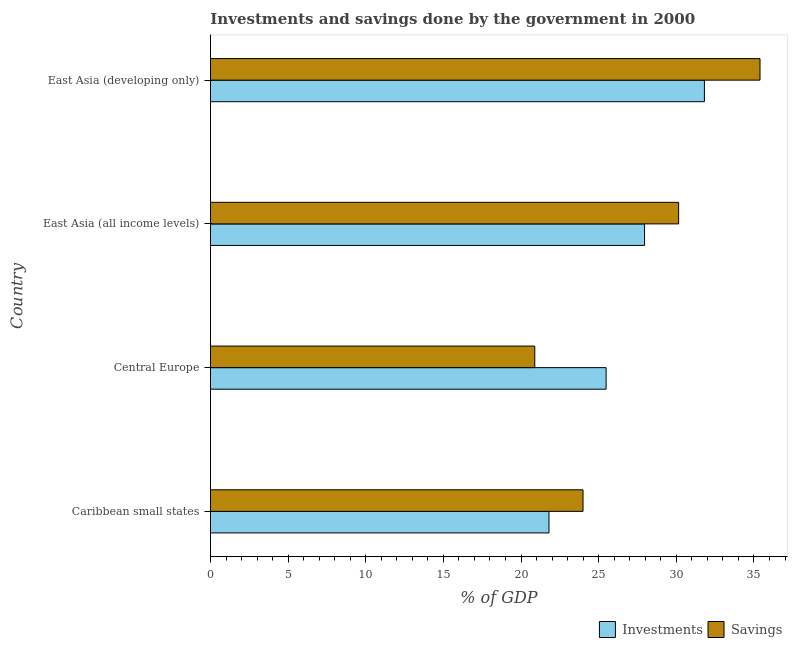How many groups of bars are there?
Your response must be concise. 4. Are the number of bars on each tick of the Y-axis equal?
Offer a terse response. Yes. How many bars are there on the 1st tick from the top?
Ensure brevity in your answer.  2. How many bars are there on the 3rd tick from the bottom?
Make the answer very short. 2. What is the label of the 4th group of bars from the top?
Offer a terse response. Caribbean small states. What is the investments of government in Central Europe?
Make the answer very short. 25.48. Across all countries, what is the maximum savings of government?
Offer a very short reply. 35.39. Across all countries, what is the minimum savings of government?
Your response must be concise. 20.89. In which country was the savings of government maximum?
Your answer should be compact. East Asia (developing only). In which country was the investments of government minimum?
Ensure brevity in your answer.  Caribbean small states. What is the total savings of government in the graph?
Keep it short and to the point. 110.42. What is the difference between the investments of government in East Asia (all income levels) and that in East Asia (developing only)?
Keep it short and to the point. -3.85. What is the difference between the savings of government in Caribbean small states and the investments of government in East Asia (all income levels)?
Ensure brevity in your answer.  -3.96. What is the average savings of government per country?
Offer a terse response. 27.61. What is the difference between the savings of government and investments of government in Central Europe?
Give a very brief answer. -4.59. In how many countries, is the savings of government greater than 18 %?
Your answer should be compact. 4. What is the ratio of the investments of government in East Asia (all income levels) to that in East Asia (developing only)?
Ensure brevity in your answer.  0.88. Is the investments of government in Caribbean small states less than that in Central Europe?
Offer a very short reply. Yes. What is the difference between the highest and the second highest investments of government?
Give a very brief answer. 3.85. What is the difference between the highest and the lowest savings of government?
Give a very brief answer. 14.51. In how many countries, is the investments of government greater than the average investments of government taken over all countries?
Provide a short and direct response. 2. Is the sum of the investments of government in Caribbean small states and East Asia (developing only) greater than the maximum savings of government across all countries?
Make the answer very short. Yes. What does the 1st bar from the top in Central Europe represents?
Your response must be concise. Savings. What does the 1st bar from the bottom in East Asia (all income levels) represents?
Ensure brevity in your answer.  Investments. Are all the bars in the graph horizontal?
Make the answer very short. Yes. How many countries are there in the graph?
Offer a very short reply. 4. What is the difference between two consecutive major ticks on the X-axis?
Provide a short and direct response. 5. Does the graph contain any zero values?
Give a very brief answer. No. Does the graph contain grids?
Ensure brevity in your answer.  No. Where does the legend appear in the graph?
Offer a very short reply. Bottom right. How many legend labels are there?
Provide a succinct answer. 2. What is the title of the graph?
Give a very brief answer. Investments and savings done by the government in 2000. Does "Domestic Liabilities" appear as one of the legend labels in the graph?
Keep it short and to the point. No. What is the label or title of the X-axis?
Give a very brief answer. % of GDP. What is the label or title of the Y-axis?
Keep it short and to the point. Country. What is the % of GDP of Investments in Caribbean small states?
Give a very brief answer. 21.8. What is the % of GDP of Savings in Caribbean small states?
Provide a short and direct response. 23.99. What is the % of GDP in Investments in Central Europe?
Make the answer very short. 25.48. What is the % of GDP in Savings in Central Europe?
Your answer should be compact. 20.89. What is the % of GDP in Investments in East Asia (all income levels)?
Give a very brief answer. 27.96. What is the % of GDP in Savings in East Asia (all income levels)?
Give a very brief answer. 30.15. What is the % of GDP in Investments in East Asia (developing only)?
Make the answer very short. 31.81. What is the % of GDP of Savings in East Asia (developing only)?
Your response must be concise. 35.39. Across all countries, what is the maximum % of GDP in Investments?
Your answer should be compact. 31.81. Across all countries, what is the maximum % of GDP in Savings?
Offer a very short reply. 35.39. Across all countries, what is the minimum % of GDP of Investments?
Your response must be concise. 21.8. Across all countries, what is the minimum % of GDP in Savings?
Provide a short and direct response. 20.89. What is the total % of GDP in Investments in the graph?
Keep it short and to the point. 107.04. What is the total % of GDP in Savings in the graph?
Keep it short and to the point. 110.42. What is the difference between the % of GDP of Investments in Caribbean small states and that in Central Europe?
Your answer should be very brief. -3.68. What is the difference between the % of GDP of Savings in Caribbean small states and that in Central Europe?
Your answer should be very brief. 3.11. What is the difference between the % of GDP of Investments in Caribbean small states and that in East Asia (all income levels)?
Your answer should be very brief. -6.16. What is the difference between the % of GDP in Savings in Caribbean small states and that in East Asia (all income levels)?
Give a very brief answer. -6.16. What is the difference between the % of GDP of Investments in Caribbean small states and that in East Asia (developing only)?
Make the answer very short. -10.01. What is the difference between the % of GDP in Savings in Caribbean small states and that in East Asia (developing only)?
Your response must be concise. -11.4. What is the difference between the % of GDP in Investments in Central Europe and that in East Asia (all income levels)?
Your answer should be compact. -2.48. What is the difference between the % of GDP in Savings in Central Europe and that in East Asia (all income levels)?
Provide a short and direct response. -9.26. What is the difference between the % of GDP of Investments in Central Europe and that in East Asia (developing only)?
Your answer should be compact. -6.33. What is the difference between the % of GDP of Savings in Central Europe and that in East Asia (developing only)?
Provide a short and direct response. -14.51. What is the difference between the % of GDP of Investments in East Asia (all income levels) and that in East Asia (developing only)?
Make the answer very short. -3.85. What is the difference between the % of GDP of Savings in East Asia (all income levels) and that in East Asia (developing only)?
Give a very brief answer. -5.24. What is the difference between the % of GDP of Investments in Caribbean small states and the % of GDP of Savings in Central Europe?
Keep it short and to the point. 0.91. What is the difference between the % of GDP of Investments in Caribbean small states and the % of GDP of Savings in East Asia (all income levels)?
Offer a terse response. -8.35. What is the difference between the % of GDP in Investments in Caribbean small states and the % of GDP in Savings in East Asia (developing only)?
Give a very brief answer. -13.59. What is the difference between the % of GDP in Investments in Central Europe and the % of GDP in Savings in East Asia (all income levels)?
Your response must be concise. -4.67. What is the difference between the % of GDP of Investments in Central Europe and the % of GDP of Savings in East Asia (developing only)?
Provide a succinct answer. -9.91. What is the difference between the % of GDP in Investments in East Asia (all income levels) and the % of GDP in Savings in East Asia (developing only)?
Ensure brevity in your answer.  -7.44. What is the average % of GDP of Investments per country?
Provide a succinct answer. 26.76. What is the average % of GDP in Savings per country?
Keep it short and to the point. 27.61. What is the difference between the % of GDP in Investments and % of GDP in Savings in Caribbean small states?
Give a very brief answer. -2.19. What is the difference between the % of GDP of Investments and % of GDP of Savings in Central Europe?
Your answer should be compact. 4.59. What is the difference between the % of GDP in Investments and % of GDP in Savings in East Asia (all income levels)?
Your answer should be very brief. -2.2. What is the difference between the % of GDP of Investments and % of GDP of Savings in East Asia (developing only)?
Provide a short and direct response. -3.58. What is the ratio of the % of GDP of Investments in Caribbean small states to that in Central Europe?
Make the answer very short. 0.86. What is the ratio of the % of GDP in Savings in Caribbean small states to that in Central Europe?
Keep it short and to the point. 1.15. What is the ratio of the % of GDP of Investments in Caribbean small states to that in East Asia (all income levels)?
Your response must be concise. 0.78. What is the ratio of the % of GDP in Savings in Caribbean small states to that in East Asia (all income levels)?
Provide a succinct answer. 0.8. What is the ratio of the % of GDP of Investments in Caribbean small states to that in East Asia (developing only)?
Offer a terse response. 0.69. What is the ratio of the % of GDP in Savings in Caribbean small states to that in East Asia (developing only)?
Your answer should be compact. 0.68. What is the ratio of the % of GDP of Investments in Central Europe to that in East Asia (all income levels)?
Ensure brevity in your answer.  0.91. What is the ratio of the % of GDP in Savings in Central Europe to that in East Asia (all income levels)?
Offer a terse response. 0.69. What is the ratio of the % of GDP of Investments in Central Europe to that in East Asia (developing only)?
Your response must be concise. 0.8. What is the ratio of the % of GDP in Savings in Central Europe to that in East Asia (developing only)?
Ensure brevity in your answer.  0.59. What is the ratio of the % of GDP of Investments in East Asia (all income levels) to that in East Asia (developing only)?
Offer a very short reply. 0.88. What is the ratio of the % of GDP in Savings in East Asia (all income levels) to that in East Asia (developing only)?
Offer a terse response. 0.85. What is the difference between the highest and the second highest % of GDP in Investments?
Ensure brevity in your answer.  3.85. What is the difference between the highest and the second highest % of GDP in Savings?
Keep it short and to the point. 5.24. What is the difference between the highest and the lowest % of GDP of Investments?
Give a very brief answer. 10.01. What is the difference between the highest and the lowest % of GDP of Savings?
Offer a terse response. 14.51. 